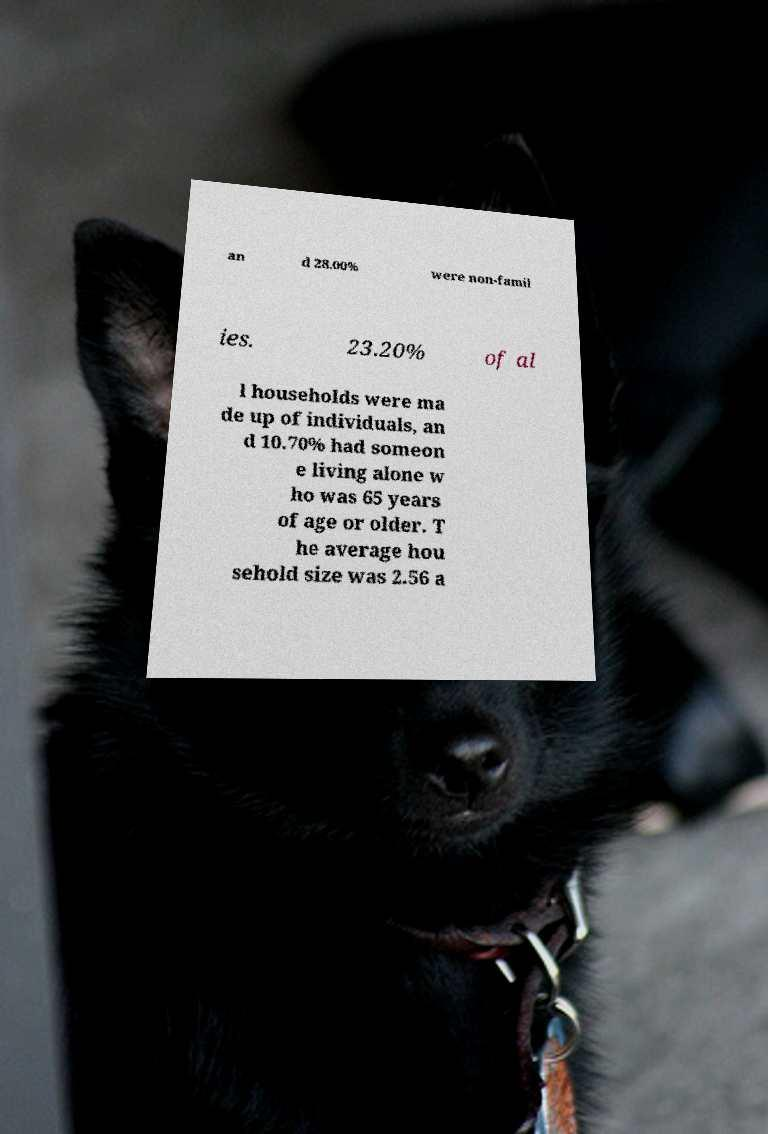Could you assist in decoding the text presented in this image and type it out clearly? an d 28.00% were non-famil ies. 23.20% of al l households were ma de up of individuals, an d 10.70% had someon e living alone w ho was 65 years of age or older. T he average hou sehold size was 2.56 a 